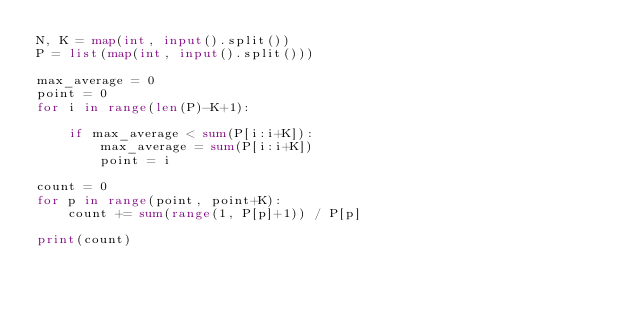<code> <loc_0><loc_0><loc_500><loc_500><_Python_>N, K = map(int, input().split())
P = list(map(int, input().split()))

max_average = 0
point = 0
for i in range(len(P)-K+1):

    if max_average < sum(P[i:i+K]):
        max_average = sum(P[i:i+K])
        point = i

count = 0
for p in range(point, point+K):
    count += sum(range(1, P[p]+1)) / P[p]

print(count)</code> 